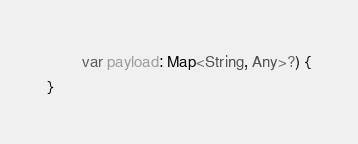Convert code to text. <code><loc_0><loc_0><loc_500><loc_500><_Kotlin_>        var payload: Map<String, Any>?) {
}</code> 